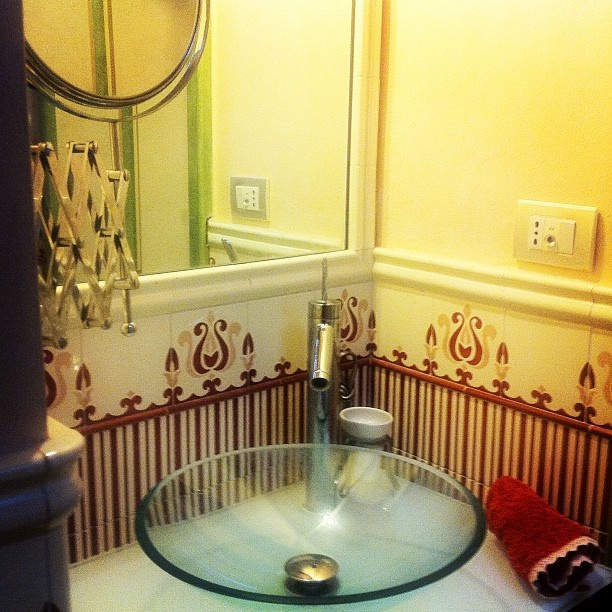Describe the objects in this image and their specific colors. I can see a sink in black, darkgray, tan, and beige tones in this image. 